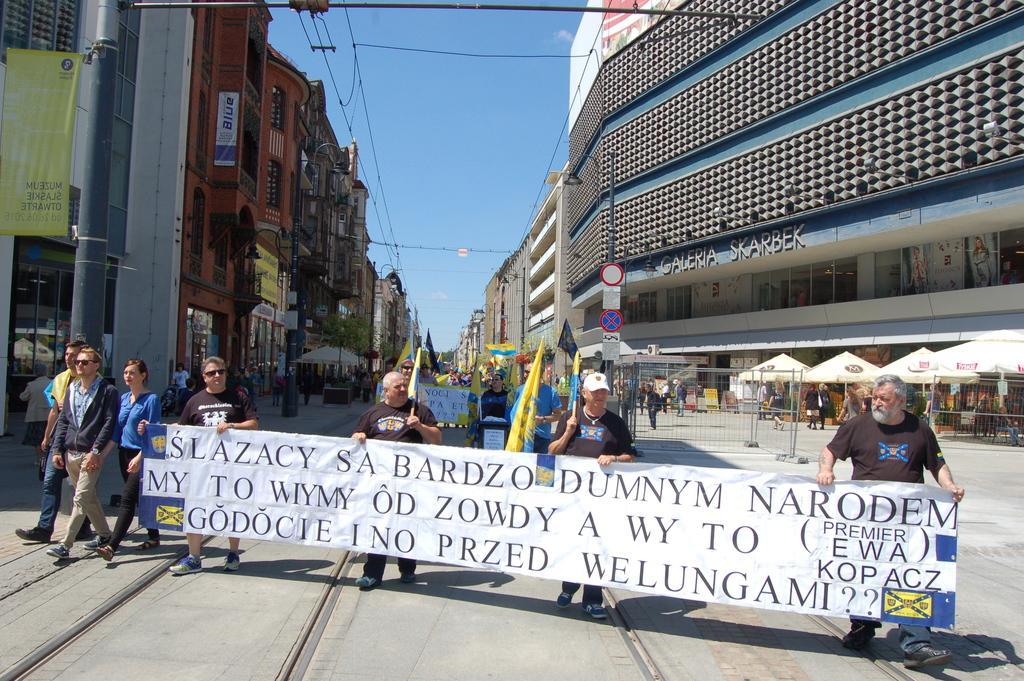Could you give a brief overview of what you see in this image? In this picture we can see a group of men standing in the front and holding the banner on which something is written. Behind we can see yellow flags and buildings on both sides. On the top there is a clear blue sky. 